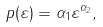<formula> <loc_0><loc_0><loc_500><loc_500>p ( \varepsilon ) = \alpha _ { 1 } \varepsilon ^ { \alpha _ { 2 } } ,</formula> 